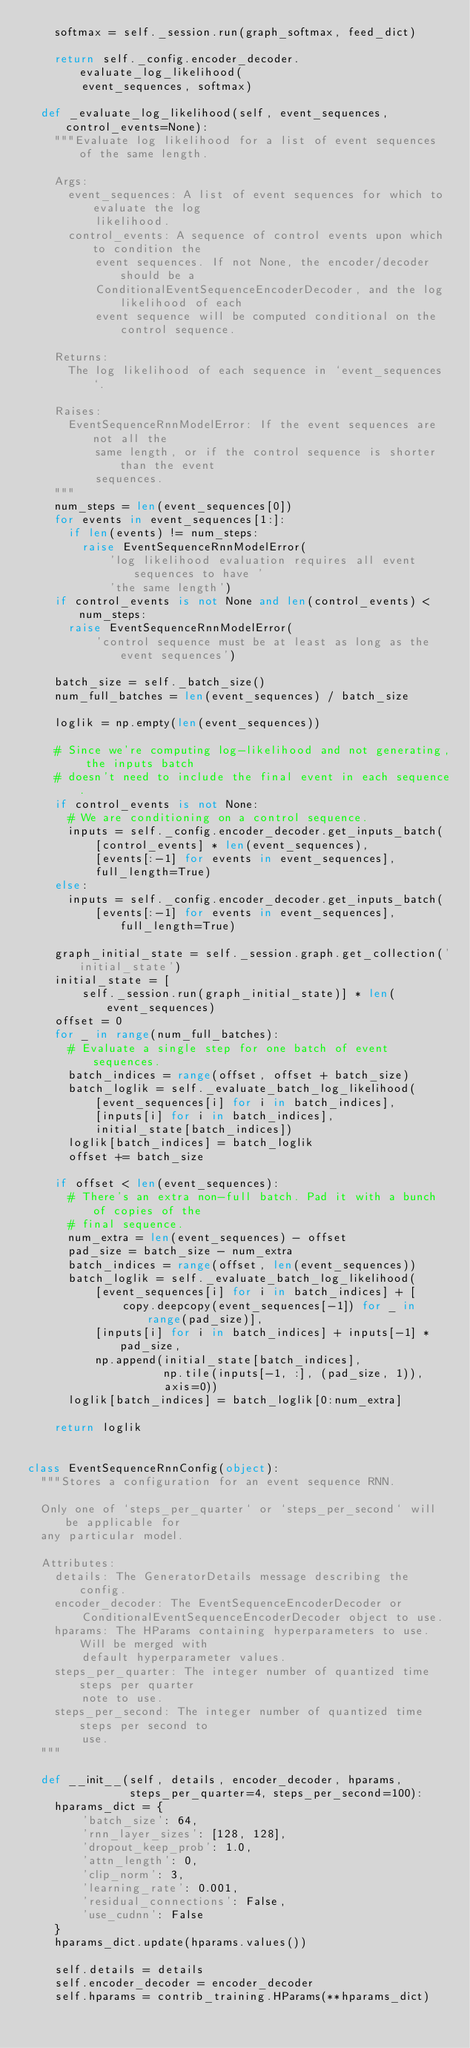<code> <loc_0><loc_0><loc_500><loc_500><_Python_>    softmax = self._session.run(graph_softmax, feed_dict)

    return self._config.encoder_decoder.evaluate_log_likelihood(
        event_sequences, softmax)

  def _evaluate_log_likelihood(self, event_sequences, control_events=None):
    """Evaluate log likelihood for a list of event sequences of the same length.

    Args:
      event_sequences: A list of event sequences for which to evaluate the log
          likelihood.
      control_events: A sequence of control events upon which to condition the
          event sequences. If not None, the encoder/decoder should be a
          ConditionalEventSequenceEncoderDecoder, and the log likelihood of each
          event sequence will be computed conditional on the control sequence.

    Returns:
      The log likelihood of each sequence in `event_sequences`.

    Raises:
      EventSequenceRnnModelError: If the event sequences are not all the
          same length, or if the control sequence is shorter than the event
          sequences.
    """
    num_steps = len(event_sequences[0])
    for events in event_sequences[1:]:
      if len(events) != num_steps:
        raise EventSequenceRnnModelError(
            'log likelihood evaluation requires all event sequences to have '
            'the same length')
    if control_events is not None and len(control_events) < num_steps:
      raise EventSequenceRnnModelError(
          'control sequence must be at least as long as the event sequences')

    batch_size = self._batch_size()
    num_full_batches = len(event_sequences) / batch_size

    loglik = np.empty(len(event_sequences))

    # Since we're computing log-likelihood and not generating, the inputs batch
    # doesn't need to include the final event in each sequence.
    if control_events is not None:
      # We are conditioning on a control sequence.
      inputs = self._config.encoder_decoder.get_inputs_batch(
          [control_events] * len(event_sequences),
          [events[:-1] for events in event_sequences],
          full_length=True)
    else:
      inputs = self._config.encoder_decoder.get_inputs_batch(
          [events[:-1] for events in event_sequences], full_length=True)

    graph_initial_state = self._session.graph.get_collection('initial_state')
    initial_state = [
        self._session.run(graph_initial_state)] * len(event_sequences)
    offset = 0
    for _ in range(num_full_batches):
      # Evaluate a single step for one batch of event sequences.
      batch_indices = range(offset, offset + batch_size)
      batch_loglik = self._evaluate_batch_log_likelihood(
          [event_sequences[i] for i in batch_indices],
          [inputs[i] for i in batch_indices],
          initial_state[batch_indices])
      loglik[batch_indices] = batch_loglik
      offset += batch_size

    if offset < len(event_sequences):
      # There's an extra non-full batch. Pad it with a bunch of copies of the
      # final sequence.
      num_extra = len(event_sequences) - offset
      pad_size = batch_size - num_extra
      batch_indices = range(offset, len(event_sequences))
      batch_loglik = self._evaluate_batch_log_likelihood(
          [event_sequences[i] for i in batch_indices] + [
              copy.deepcopy(event_sequences[-1]) for _ in range(pad_size)],
          [inputs[i] for i in batch_indices] + inputs[-1] * pad_size,
          np.append(initial_state[batch_indices],
                    np.tile(inputs[-1, :], (pad_size, 1)),
                    axis=0))
      loglik[batch_indices] = batch_loglik[0:num_extra]

    return loglik


class EventSequenceRnnConfig(object):
  """Stores a configuration for an event sequence RNN.

  Only one of `steps_per_quarter` or `steps_per_second` will be applicable for
  any particular model.

  Attributes:
    details: The GeneratorDetails message describing the config.
    encoder_decoder: The EventSequenceEncoderDecoder or
        ConditionalEventSequenceEncoderDecoder object to use.
    hparams: The HParams containing hyperparameters to use. Will be merged with
        default hyperparameter values.
    steps_per_quarter: The integer number of quantized time steps per quarter
        note to use.
    steps_per_second: The integer number of quantized time steps per second to
        use.
  """

  def __init__(self, details, encoder_decoder, hparams,
               steps_per_quarter=4, steps_per_second=100):
    hparams_dict = {
        'batch_size': 64,
        'rnn_layer_sizes': [128, 128],
        'dropout_keep_prob': 1.0,
        'attn_length': 0,
        'clip_norm': 3,
        'learning_rate': 0.001,
        'residual_connections': False,
        'use_cudnn': False
    }
    hparams_dict.update(hparams.values())

    self.details = details
    self.encoder_decoder = encoder_decoder
    self.hparams = contrib_training.HParams(**hparams_dict)</code> 